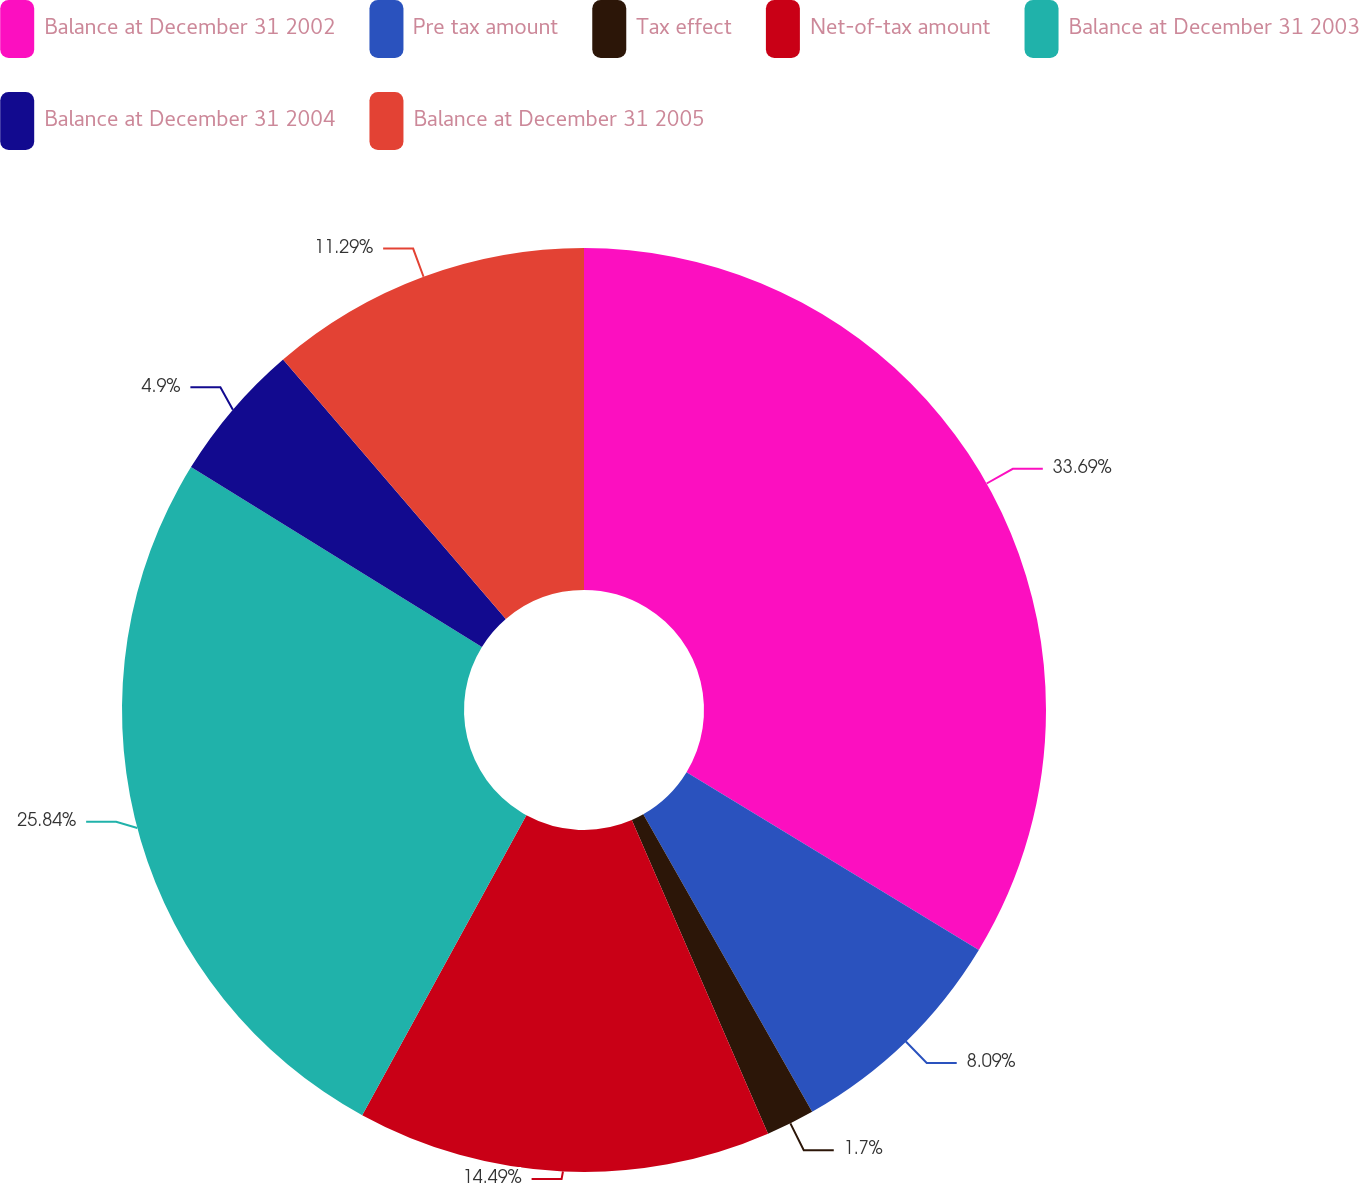<chart> <loc_0><loc_0><loc_500><loc_500><pie_chart><fcel>Balance at December 31 2002<fcel>Pre tax amount<fcel>Tax effect<fcel>Net-of-tax amount<fcel>Balance at December 31 2003<fcel>Balance at December 31 2004<fcel>Balance at December 31 2005<nl><fcel>33.69%<fcel>8.09%<fcel>1.7%<fcel>14.49%<fcel>25.84%<fcel>4.9%<fcel>11.29%<nl></chart> 